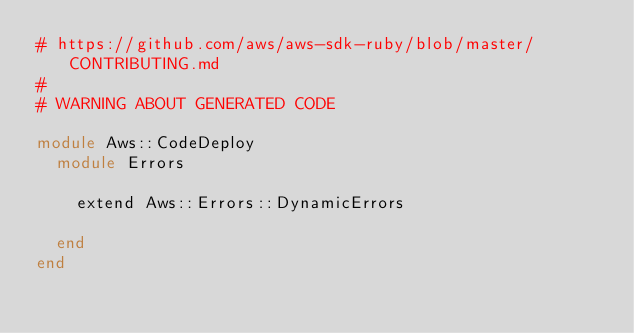<code> <loc_0><loc_0><loc_500><loc_500><_Ruby_># https://github.com/aws/aws-sdk-ruby/blob/master/CONTRIBUTING.md
#
# WARNING ABOUT GENERATED CODE

module Aws::CodeDeploy
  module Errors

    extend Aws::Errors::DynamicErrors

  end
end
</code> 